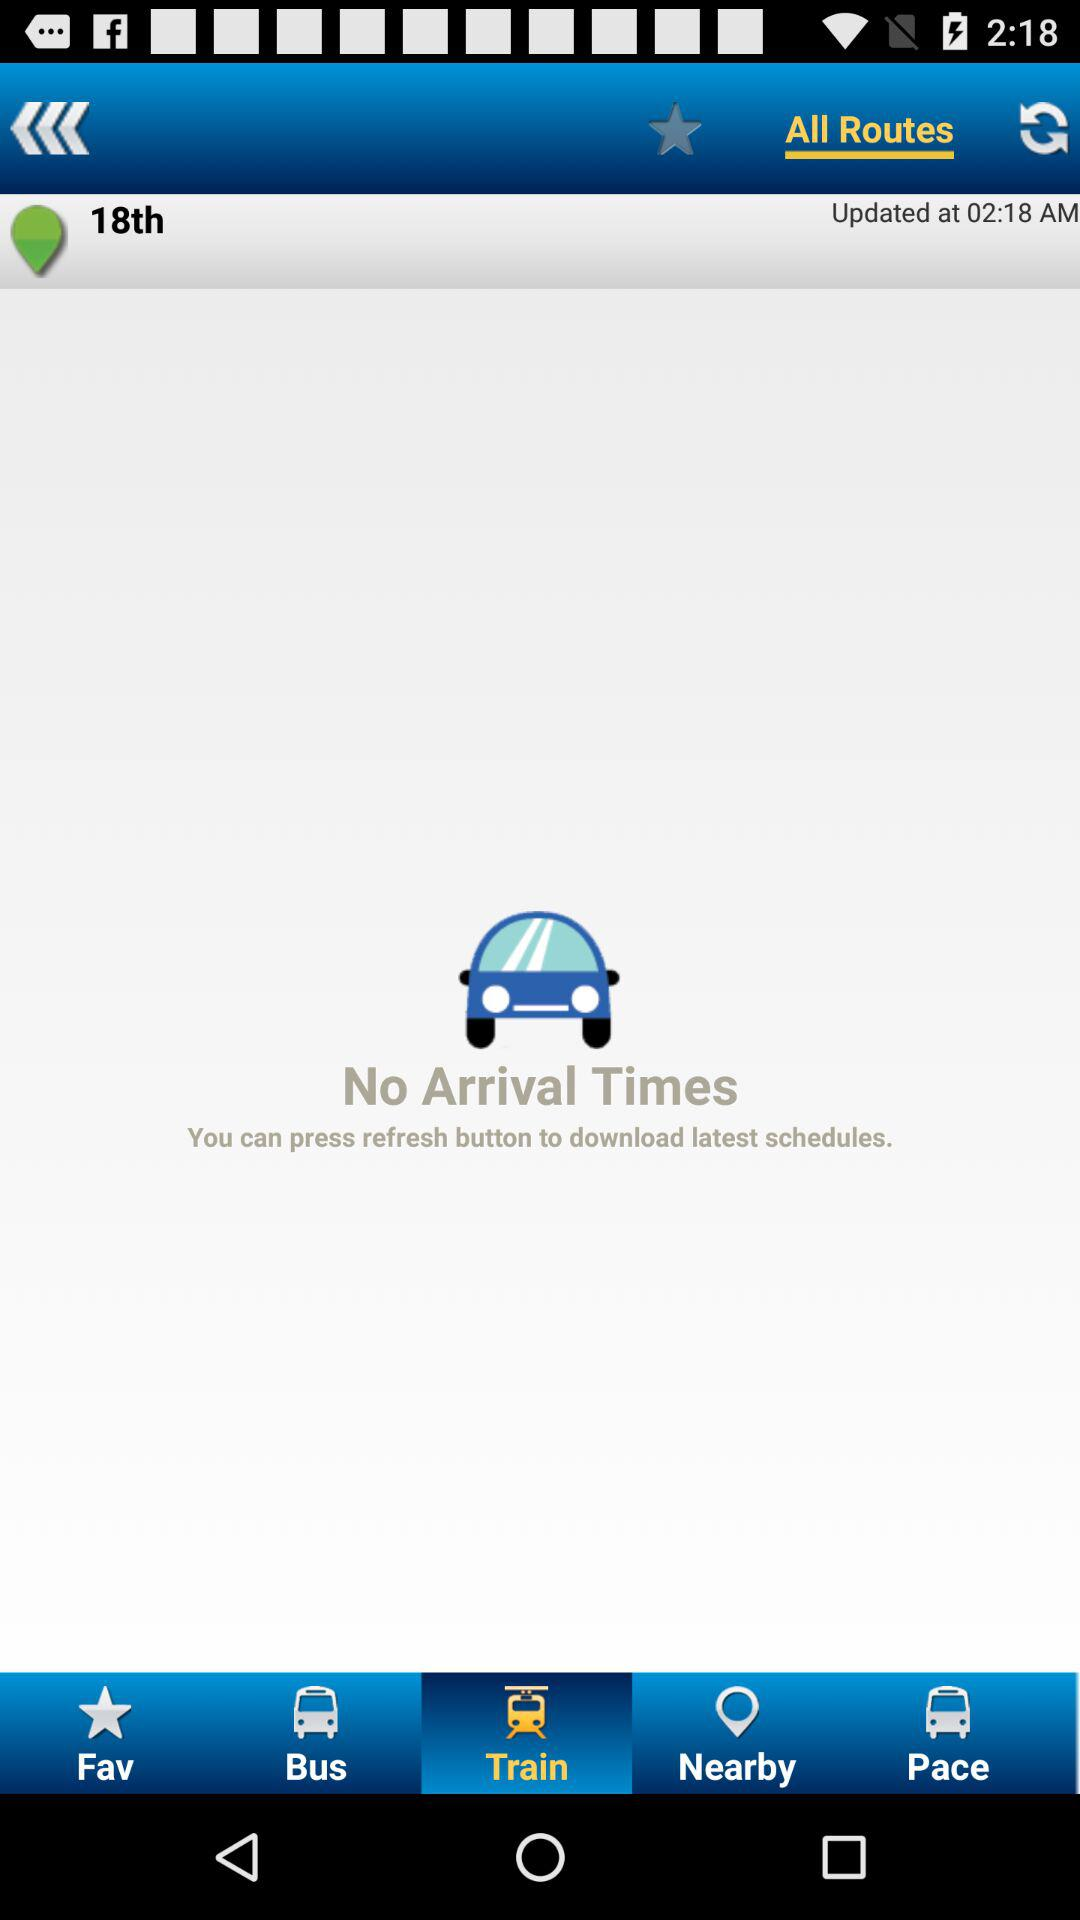Which tab is selected? The selected tab is "Train". 